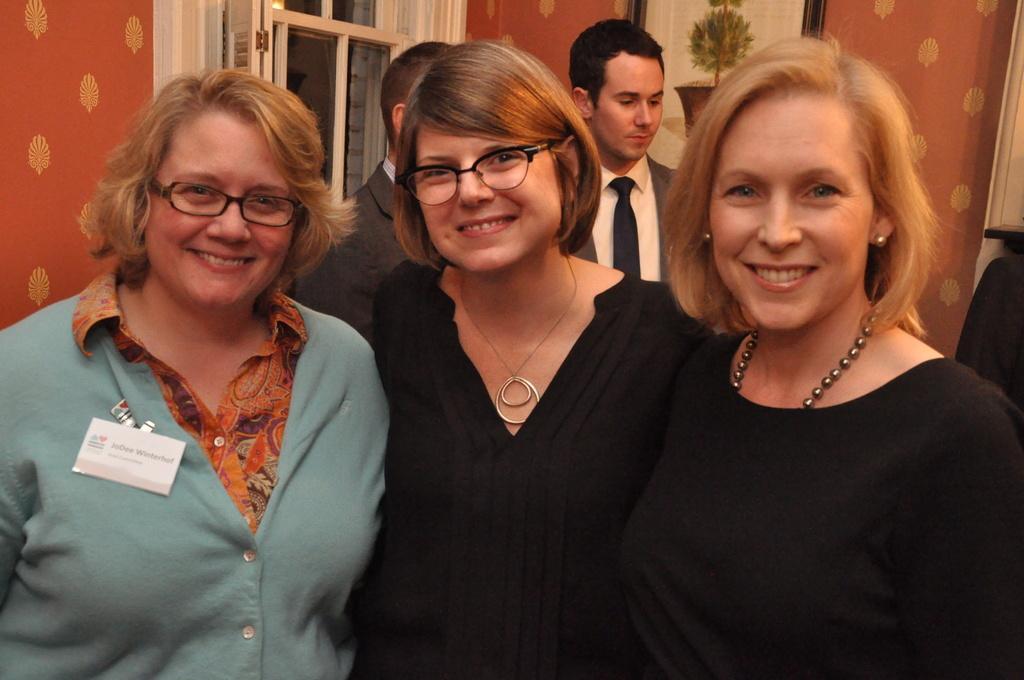Describe this image in one or two sentences. At the bottom of this image, there are three women smiling and standing. In the background, there are two men in suits, standing, there are photo frames attached to a wall and there is a door. 